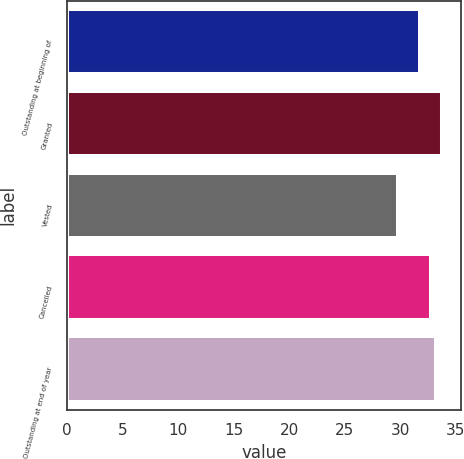<chart> <loc_0><loc_0><loc_500><loc_500><bar_chart><fcel>Outstanding at beginning of<fcel>Granted<fcel>Vested<fcel>Cancelled<fcel>Outstanding at end of year<nl><fcel>31.77<fcel>33.75<fcel>29.83<fcel>32.82<fcel>33.21<nl></chart> 